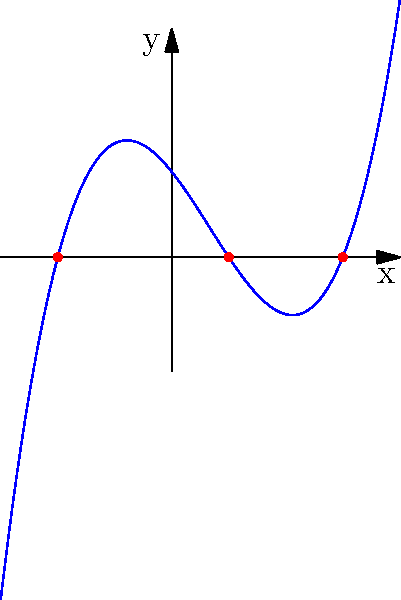The graph of a cubic polynomial $f(x)$ is shown above. What are the roots of this polynomial? To find the roots of a polynomial, we need to identify where the graph crosses the x-axis. These points represent the solutions to the equation $f(x) = 0$.

Step 1: Observe the graph and identify the x-intercepts.
The graph crosses the x-axis at three points.

Step 2: Determine the x-coordinates of these points.
From the graph, we can see that the x-intercepts occur at:
- x = -2
- x = 1
- x = 3

Step 3: Conclude that these x-coordinates are the roots of the polynomial.
The roots of a polynomial are the values of x that make $f(x) = 0$, which correspond to the x-intercepts of its graph.

Therefore, the roots of this cubic polynomial are -2, 1, and 3.
Answer: $-2, 1, 3$ 